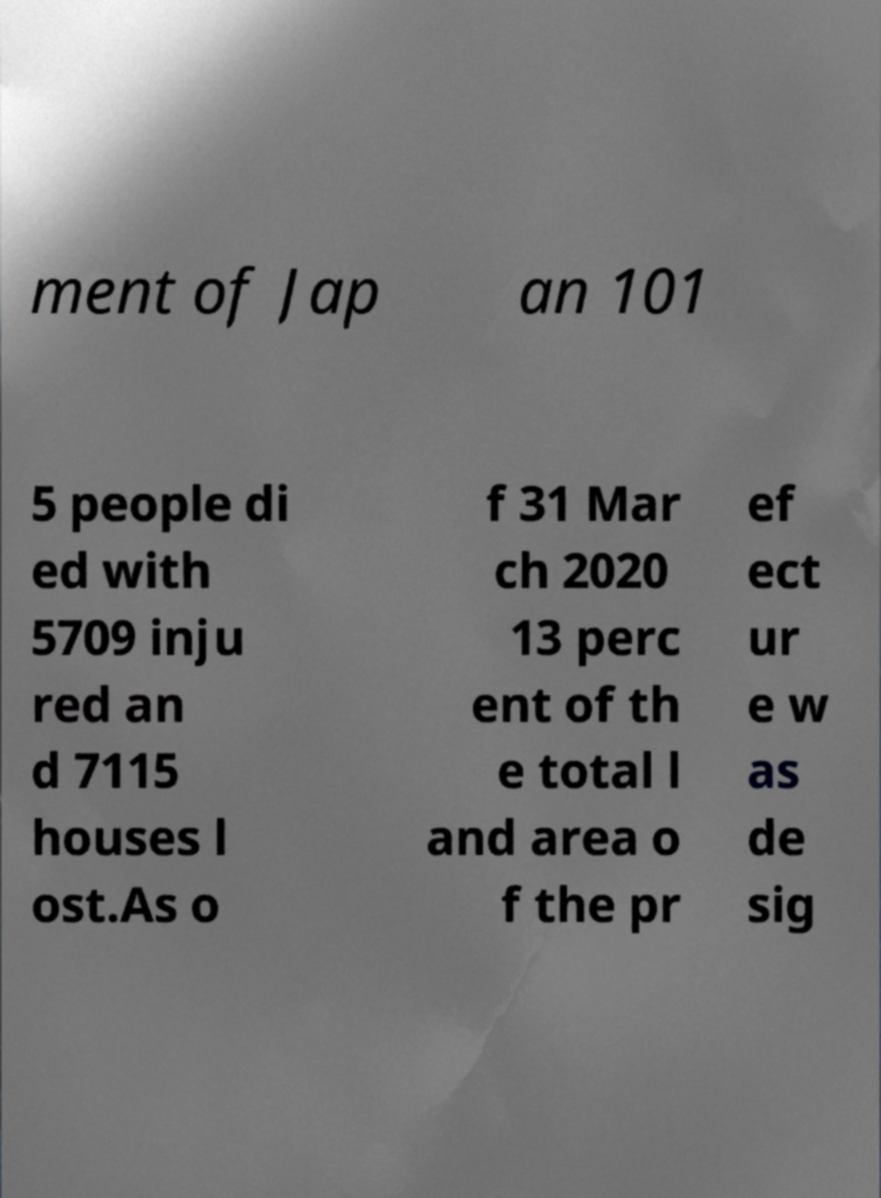I need the written content from this picture converted into text. Can you do that? ment of Jap an 101 5 people di ed with 5709 inju red an d 7115 houses l ost.As o f 31 Mar ch 2020 13 perc ent of th e total l and area o f the pr ef ect ur e w as de sig 